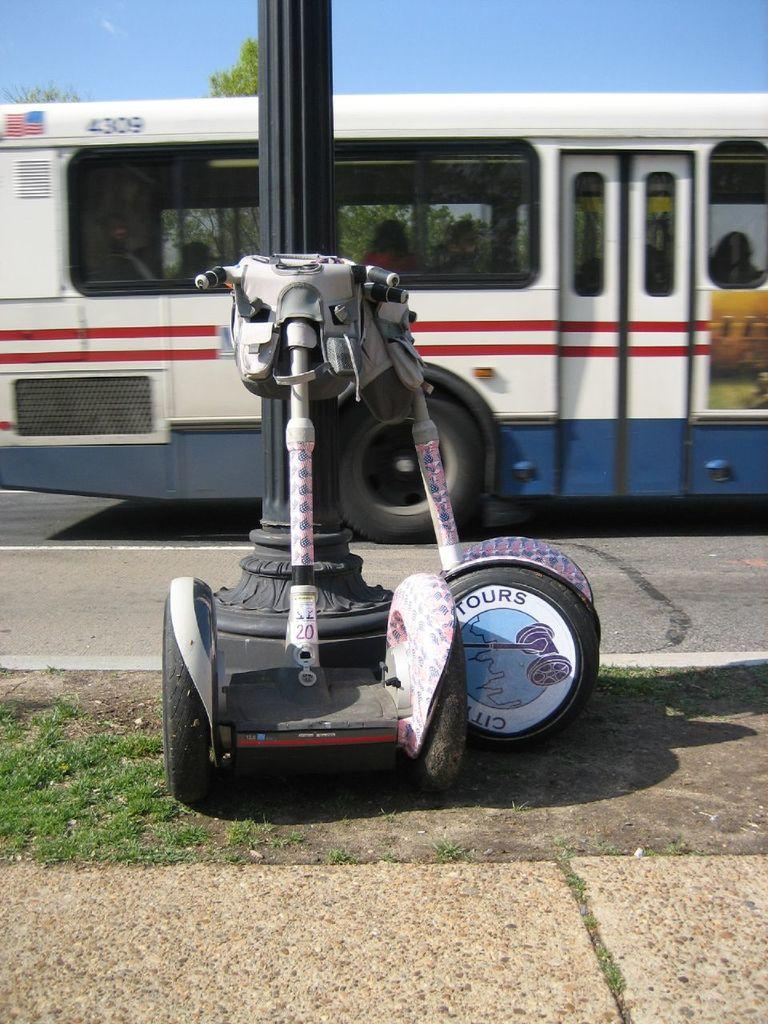What type of vehicle is on the road in the image? There is a bus on the road in the image. What other vehicles can be seen in the image? There are electric vehicles beside a pole in the image. What is visible at the top of the image? The sky is visible at the top of the image. Where is the girl playing with snails in the image? There is no girl or snails present in the image. What type of plant is growing near the electric vehicles in the image? There is no plant visible near the electric vehicles in the image. 